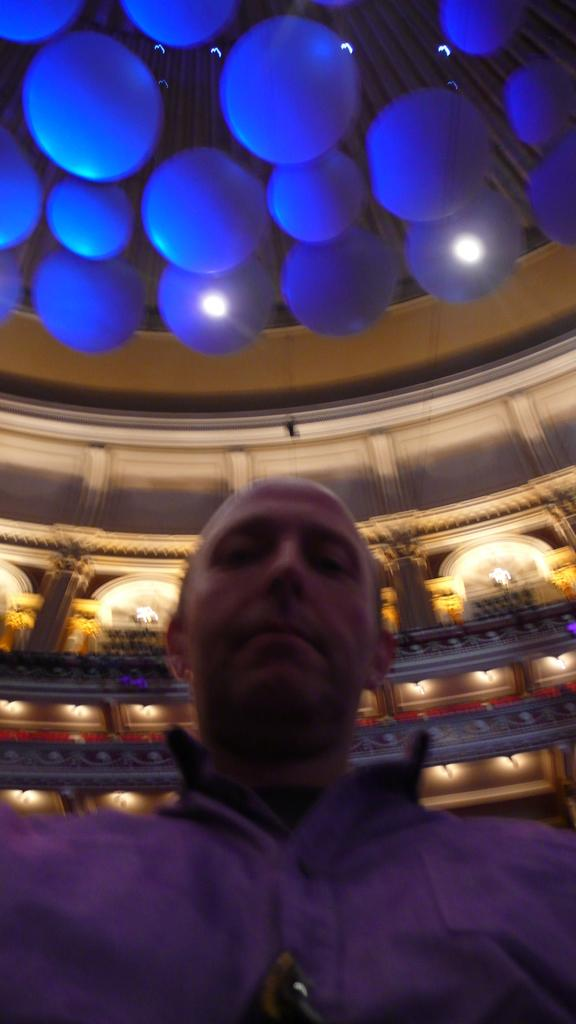Who is present in the image? There is a man in the image. What can be seen in the background of the image? There is a wall in the background of the image. What is illuminated in the image? Lights are visible in the image. What is at the top of the image? There are decorations at the top of the image. What type of sand is used for the religious ceremony in the image? There is no sand or religious ceremony present in the image. 